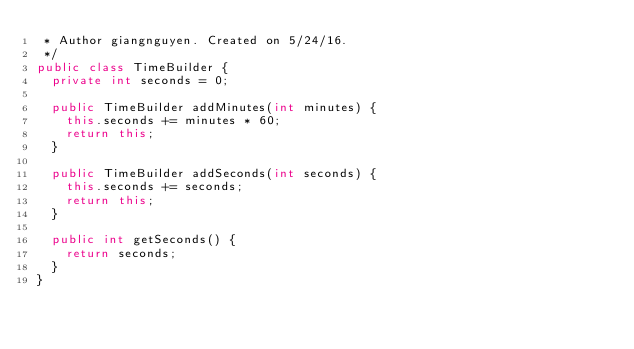Convert code to text. <code><loc_0><loc_0><loc_500><loc_500><_Java_> * Author giangnguyen. Created on 5/24/16.
 */
public class TimeBuilder {
  private int seconds = 0;

  public TimeBuilder addMinutes(int minutes) {
    this.seconds += minutes * 60;
    return this;
  }

  public TimeBuilder addSeconds(int seconds) {
    this.seconds += seconds;
    return this;
  }

  public int getSeconds() {
    return seconds;
  }
}
</code> 